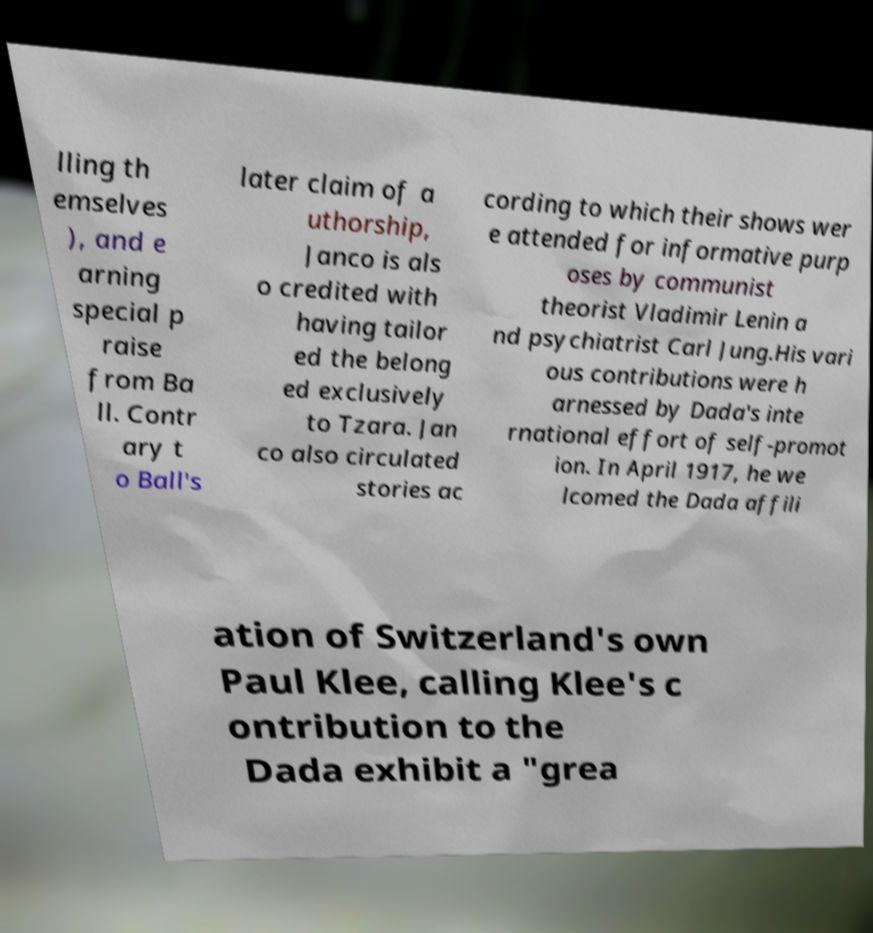Can you accurately transcribe the text from the provided image for me? lling th emselves ), and e arning special p raise from Ba ll. Contr ary t o Ball's later claim of a uthorship, Janco is als o credited with having tailor ed the belong ed exclusively to Tzara. Jan co also circulated stories ac cording to which their shows wer e attended for informative purp oses by communist theorist Vladimir Lenin a nd psychiatrist Carl Jung.His vari ous contributions were h arnessed by Dada's inte rnational effort of self-promot ion. In April 1917, he we lcomed the Dada affili ation of Switzerland's own Paul Klee, calling Klee's c ontribution to the Dada exhibit a "grea 